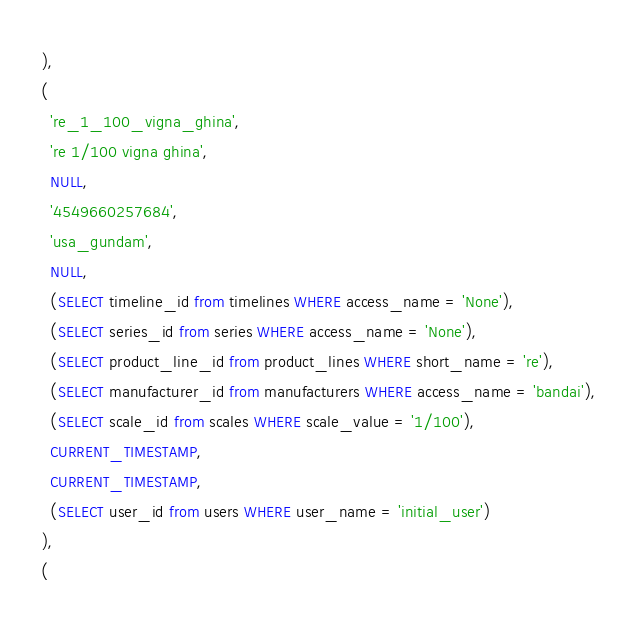<code> <loc_0><loc_0><loc_500><loc_500><_SQL_>),
(
  're_1_100_vigna_ghina',
  're 1/100 vigna ghina',
  NULL,
  '4549660257684',
  'usa_gundam',
  NULL,
  (SELECT timeline_id from timelines WHERE access_name = 'None'),
  (SELECT series_id from series WHERE access_name = 'None'),
  (SELECT product_line_id from product_lines WHERE short_name = 're'),
  (SELECT manufacturer_id from manufacturers WHERE access_name = 'bandai'),
  (SELECT scale_id from scales WHERE scale_value = '1/100'),
  CURRENT_TIMESTAMP,
  CURRENT_TIMESTAMP,
  (SELECT user_id from users WHERE user_name = 'initial_user')
),
(</code> 